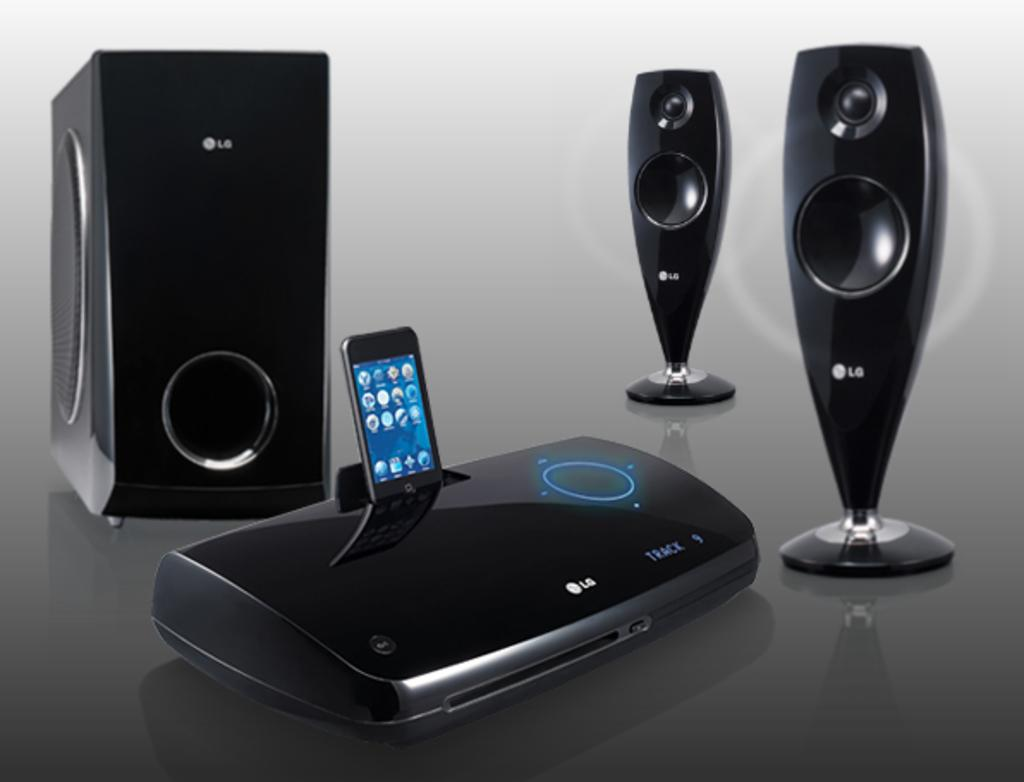<image>
Describe the image concisely. An LG music player is playing track 9 of an unknown album. 